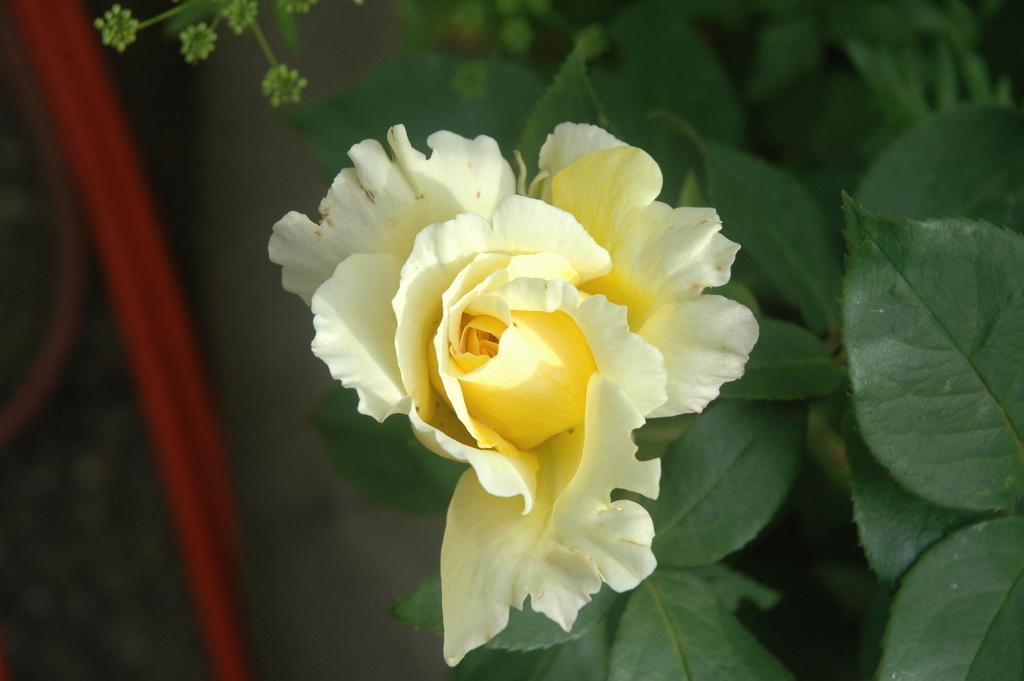What type of plant can be seen in the image? There is a flower in the image. What other parts of the plant are visible besides the flower? There are leaves in the image. Can you describe the flower's appearance? The petals of the flower are visible in the image. What type of cracker is being used to taste the flower in the image? There is no cracker present in the image, and the flower is not being tasted. 